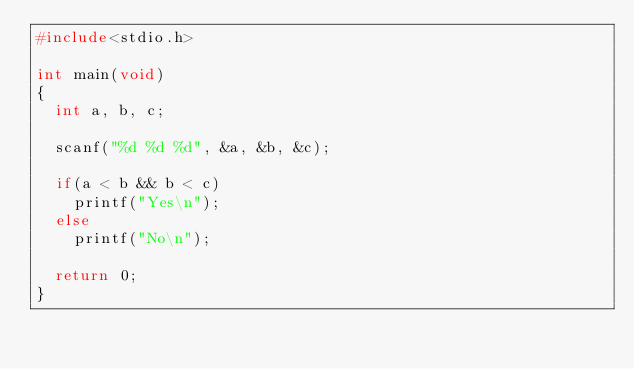<code> <loc_0><loc_0><loc_500><loc_500><_C_>#include<stdio.h>

int main(void)
{
  int a, b, c;

  scanf("%d %d %d", &a, &b, &c);

  if(a < b && b < c)
    printf("Yes\n");
  else
    printf("No\n");

  return 0;
}</code> 